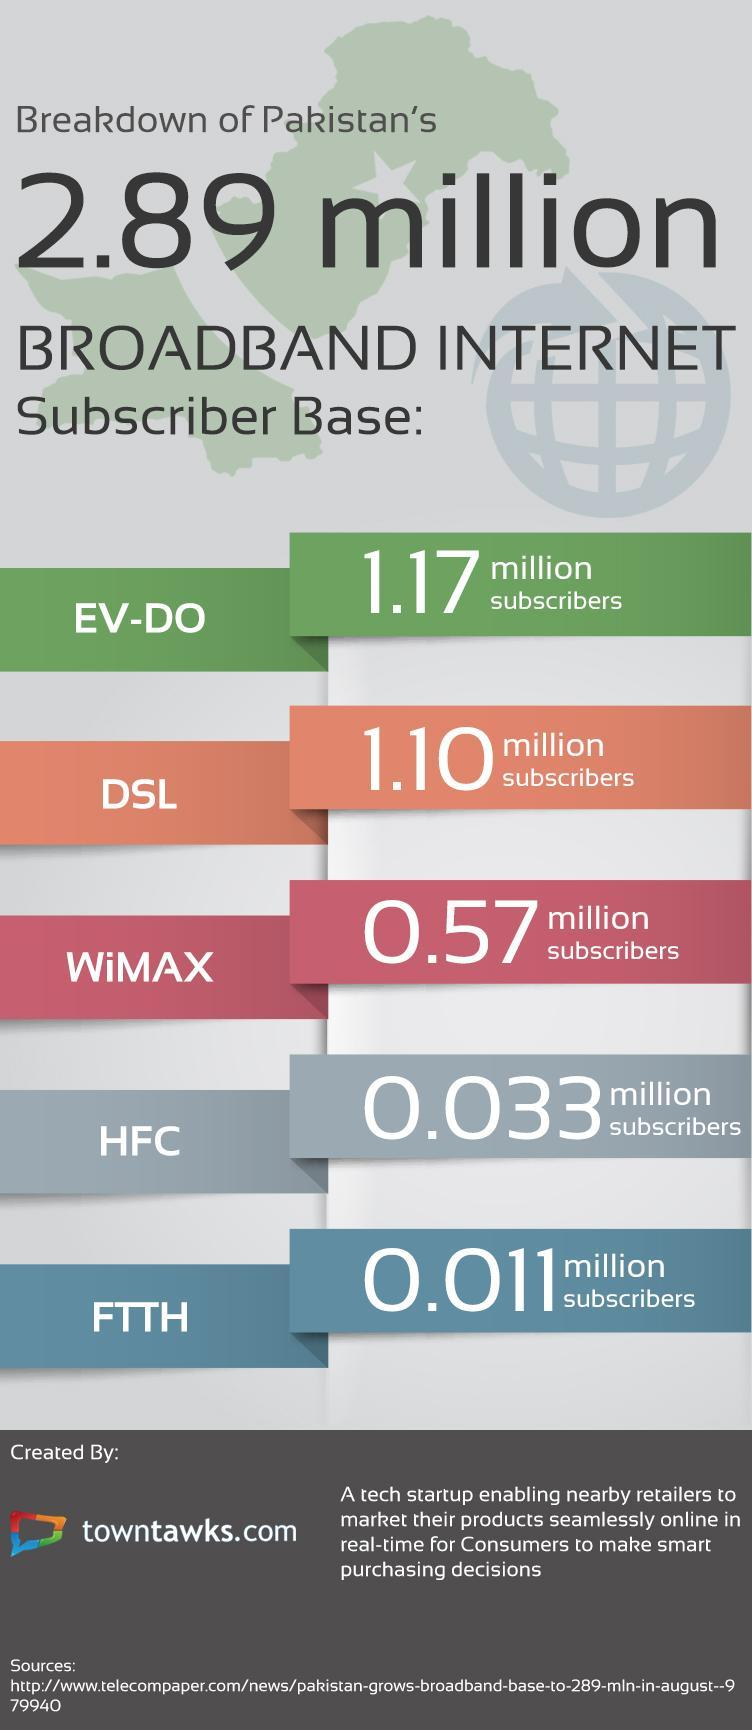Which broadband internet connection type in Pakistan has second least number of subscribers?
Answer the question with a short phrase. HFC Which broadband internet connection type in Pakistan has second highest number of subscribers? DSL Which broadband internet connection type in Pakistan has highest number of subscribers? EV-DO Which broadband internet connection type in Pakistan has least number of subscribers? FTTH 